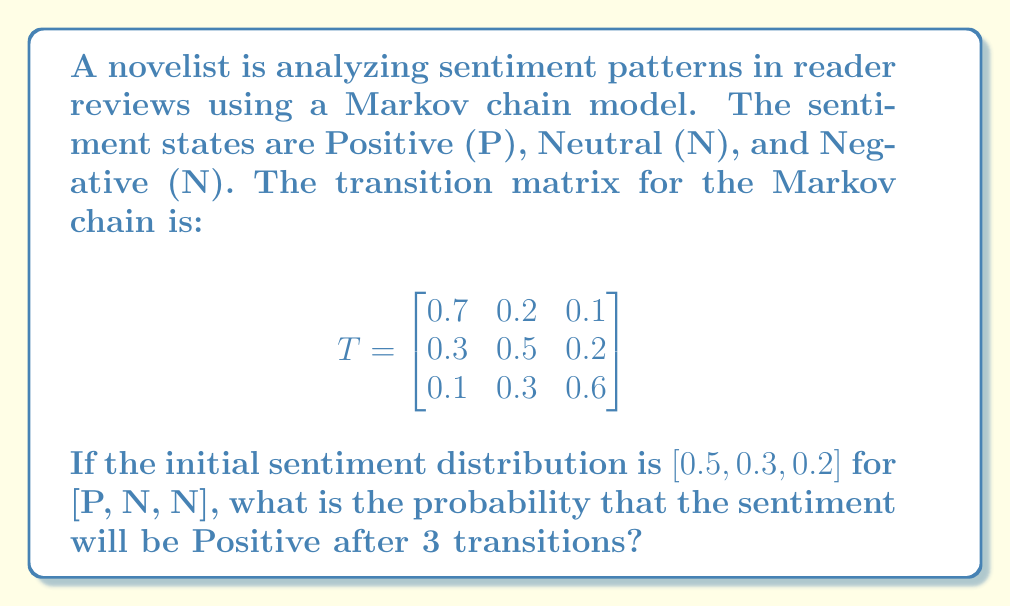What is the answer to this math problem? To solve this problem, we need to follow these steps:

1) Let's denote the initial distribution as $\pi_0 = [0.5, 0.3, 0.2]$.

2) To find the distribution after 3 transitions, we need to multiply $\pi_0$ by $T^3$ (the transition matrix raised to the power of 3).

3) First, let's calculate $T^2$:

   $$T^2 = \begin{bmatrix}
   0.7 & 0.2 & 0.1 \\
   0.3 & 0.5 & 0.2 \\
   0.1 & 0.3 & 0.6
   \end{bmatrix} \times \begin{bmatrix}
   0.7 & 0.2 & 0.1 \\
   0.3 & 0.5 & 0.2 \\
   0.1 & 0.3 & 0.6
   \end{bmatrix}$$

   $$T^2 = \begin{bmatrix}
   0.56 & 0.27 & 0.17 \\
   0.40 & 0.37 & 0.23 \\
   0.22 & 0.33 & 0.45
   \end{bmatrix}$$

4) Now, let's calculate $T^3$:

   $$T^3 = T^2 \times T = \begin{bmatrix}
   0.56 & 0.27 & 0.17 \\
   0.40 & 0.37 & 0.23 \\
   0.22 & 0.33 & 0.45
   \end{bmatrix} \times \begin{bmatrix}
   0.7 & 0.2 & 0.1 \\
   0.3 & 0.5 & 0.2 \\
   0.1 & 0.3 & 0.6
   \end{bmatrix}$$

   $$T^3 = \begin{bmatrix}
   0.497 & 0.293 & 0.210 \\
   0.418 & 0.338 & 0.244 \\
   0.295 & 0.338 & 0.367
   \end{bmatrix}$$

5) Now, we multiply $\pi_0$ by $T^3$:

   $$\pi_3 = \pi_0 \times T^3 = [0.5, 0.3, 0.2] \times \begin{bmatrix}
   0.497 & 0.293 & 0.210 \\
   0.418 & 0.338 & 0.244 \\
   0.295 & 0.338 & 0.367
   \end{bmatrix}$$

   $$\pi_3 = [0.4485, 0.3135, 0.2380]$$

6) The probability of being in the Positive state after 3 transitions is the first element of $\pi_3$, which is 0.4485.
Answer: 0.4485 